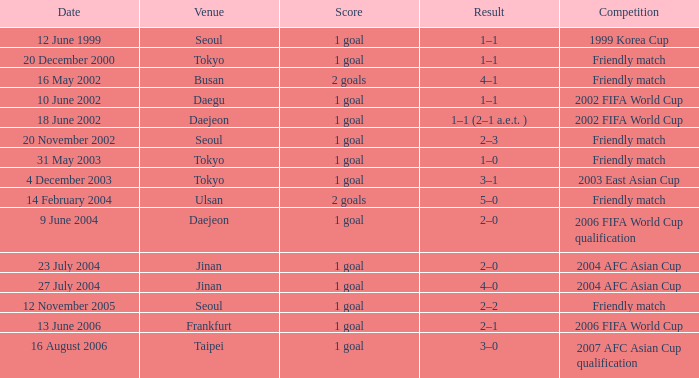What was the result of the match that took place on august 16, 2006? 1 goal. 